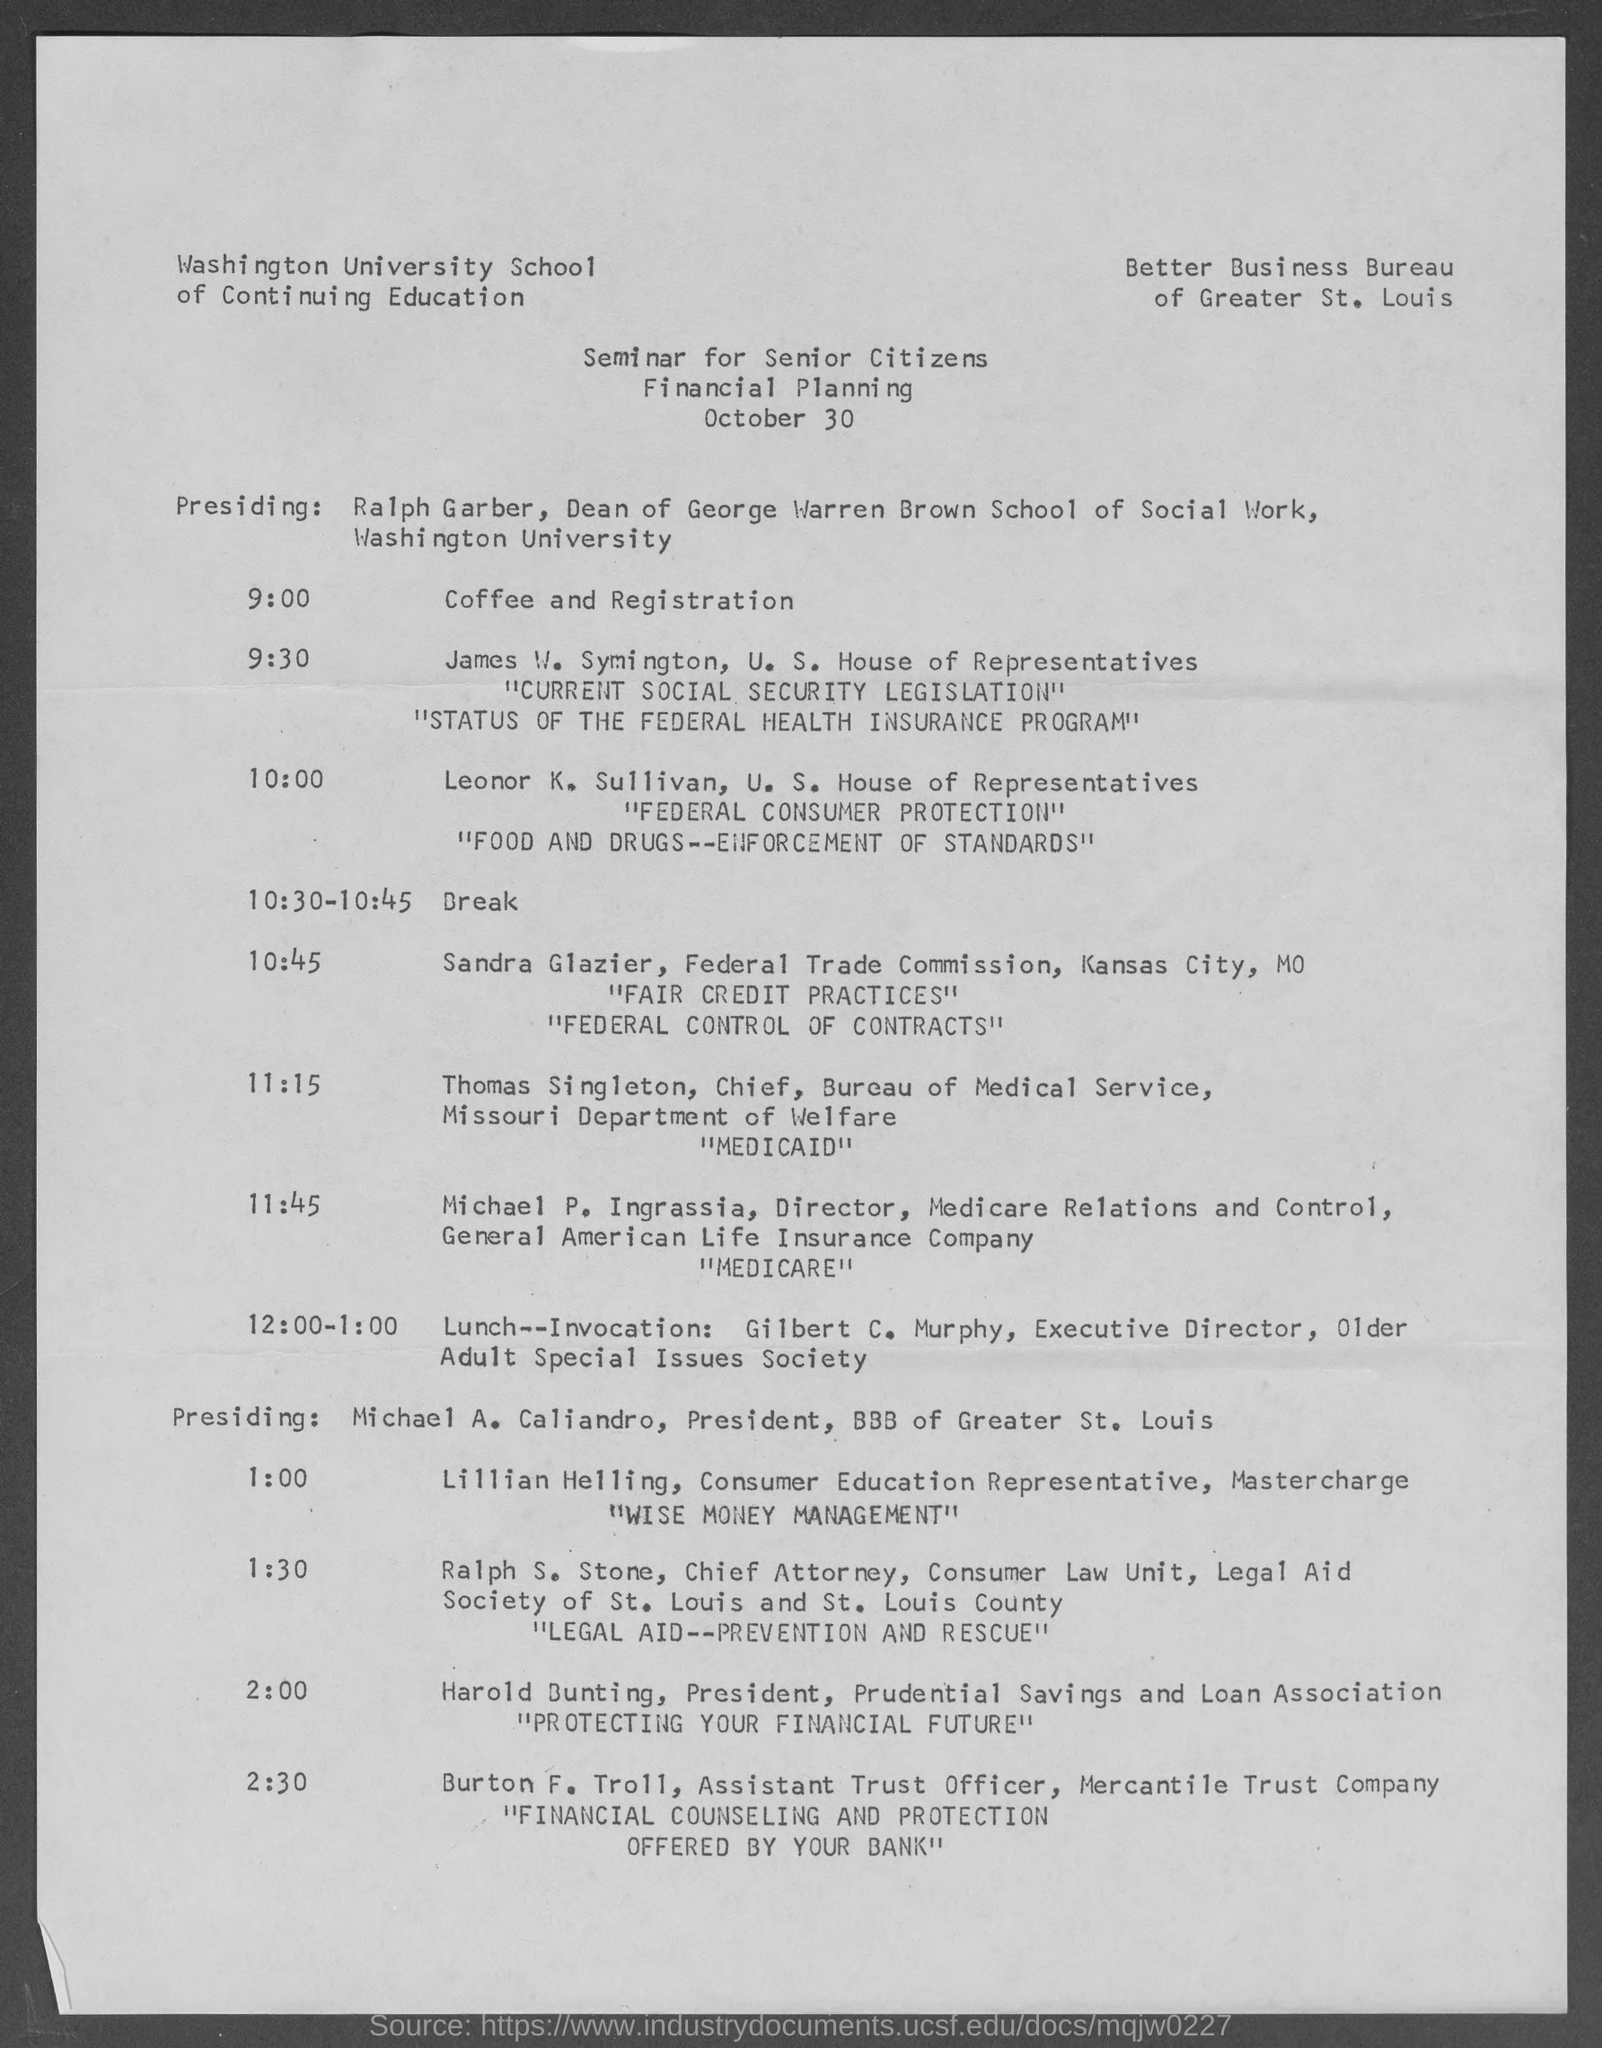List a handful of essential elements in this visual. The document, dated October 30, was found. The coffee and registration will take place at 9:00. 